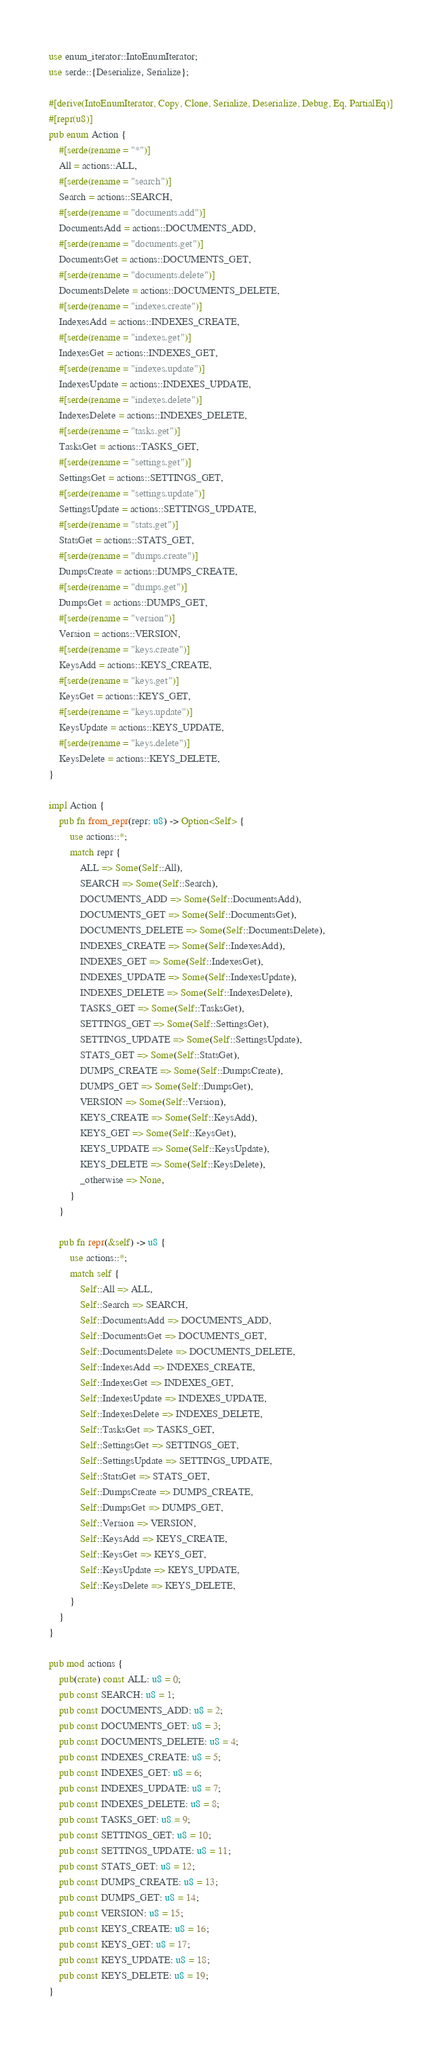<code> <loc_0><loc_0><loc_500><loc_500><_Rust_>use enum_iterator::IntoEnumIterator;
use serde::{Deserialize, Serialize};

#[derive(IntoEnumIterator, Copy, Clone, Serialize, Deserialize, Debug, Eq, PartialEq)]
#[repr(u8)]
pub enum Action {
    #[serde(rename = "*")]
    All = actions::ALL,
    #[serde(rename = "search")]
    Search = actions::SEARCH,
    #[serde(rename = "documents.add")]
    DocumentsAdd = actions::DOCUMENTS_ADD,
    #[serde(rename = "documents.get")]
    DocumentsGet = actions::DOCUMENTS_GET,
    #[serde(rename = "documents.delete")]
    DocumentsDelete = actions::DOCUMENTS_DELETE,
    #[serde(rename = "indexes.create")]
    IndexesAdd = actions::INDEXES_CREATE,
    #[serde(rename = "indexes.get")]
    IndexesGet = actions::INDEXES_GET,
    #[serde(rename = "indexes.update")]
    IndexesUpdate = actions::INDEXES_UPDATE,
    #[serde(rename = "indexes.delete")]
    IndexesDelete = actions::INDEXES_DELETE,
    #[serde(rename = "tasks.get")]
    TasksGet = actions::TASKS_GET,
    #[serde(rename = "settings.get")]
    SettingsGet = actions::SETTINGS_GET,
    #[serde(rename = "settings.update")]
    SettingsUpdate = actions::SETTINGS_UPDATE,
    #[serde(rename = "stats.get")]
    StatsGet = actions::STATS_GET,
    #[serde(rename = "dumps.create")]
    DumpsCreate = actions::DUMPS_CREATE,
    #[serde(rename = "dumps.get")]
    DumpsGet = actions::DUMPS_GET,
    #[serde(rename = "version")]
    Version = actions::VERSION,
    #[serde(rename = "keys.create")]
    KeysAdd = actions::KEYS_CREATE,
    #[serde(rename = "keys.get")]
    KeysGet = actions::KEYS_GET,
    #[serde(rename = "keys.update")]
    KeysUpdate = actions::KEYS_UPDATE,
    #[serde(rename = "keys.delete")]
    KeysDelete = actions::KEYS_DELETE,
}

impl Action {
    pub fn from_repr(repr: u8) -> Option<Self> {
        use actions::*;
        match repr {
            ALL => Some(Self::All),
            SEARCH => Some(Self::Search),
            DOCUMENTS_ADD => Some(Self::DocumentsAdd),
            DOCUMENTS_GET => Some(Self::DocumentsGet),
            DOCUMENTS_DELETE => Some(Self::DocumentsDelete),
            INDEXES_CREATE => Some(Self::IndexesAdd),
            INDEXES_GET => Some(Self::IndexesGet),
            INDEXES_UPDATE => Some(Self::IndexesUpdate),
            INDEXES_DELETE => Some(Self::IndexesDelete),
            TASKS_GET => Some(Self::TasksGet),
            SETTINGS_GET => Some(Self::SettingsGet),
            SETTINGS_UPDATE => Some(Self::SettingsUpdate),
            STATS_GET => Some(Self::StatsGet),
            DUMPS_CREATE => Some(Self::DumpsCreate),
            DUMPS_GET => Some(Self::DumpsGet),
            VERSION => Some(Self::Version),
            KEYS_CREATE => Some(Self::KeysAdd),
            KEYS_GET => Some(Self::KeysGet),
            KEYS_UPDATE => Some(Self::KeysUpdate),
            KEYS_DELETE => Some(Self::KeysDelete),
            _otherwise => None,
        }
    }

    pub fn repr(&self) -> u8 {
        use actions::*;
        match self {
            Self::All => ALL,
            Self::Search => SEARCH,
            Self::DocumentsAdd => DOCUMENTS_ADD,
            Self::DocumentsGet => DOCUMENTS_GET,
            Self::DocumentsDelete => DOCUMENTS_DELETE,
            Self::IndexesAdd => INDEXES_CREATE,
            Self::IndexesGet => INDEXES_GET,
            Self::IndexesUpdate => INDEXES_UPDATE,
            Self::IndexesDelete => INDEXES_DELETE,
            Self::TasksGet => TASKS_GET,
            Self::SettingsGet => SETTINGS_GET,
            Self::SettingsUpdate => SETTINGS_UPDATE,
            Self::StatsGet => STATS_GET,
            Self::DumpsCreate => DUMPS_CREATE,
            Self::DumpsGet => DUMPS_GET,
            Self::Version => VERSION,
            Self::KeysAdd => KEYS_CREATE,
            Self::KeysGet => KEYS_GET,
            Self::KeysUpdate => KEYS_UPDATE,
            Self::KeysDelete => KEYS_DELETE,
        }
    }
}

pub mod actions {
    pub(crate) const ALL: u8 = 0;
    pub const SEARCH: u8 = 1;
    pub const DOCUMENTS_ADD: u8 = 2;
    pub const DOCUMENTS_GET: u8 = 3;
    pub const DOCUMENTS_DELETE: u8 = 4;
    pub const INDEXES_CREATE: u8 = 5;
    pub const INDEXES_GET: u8 = 6;
    pub const INDEXES_UPDATE: u8 = 7;
    pub const INDEXES_DELETE: u8 = 8;
    pub const TASKS_GET: u8 = 9;
    pub const SETTINGS_GET: u8 = 10;
    pub const SETTINGS_UPDATE: u8 = 11;
    pub const STATS_GET: u8 = 12;
    pub const DUMPS_CREATE: u8 = 13;
    pub const DUMPS_GET: u8 = 14;
    pub const VERSION: u8 = 15;
    pub const KEYS_CREATE: u8 = 16;
    pub const KEYS_GET: u8 = 17;
    pub const KEYS_UPDATE: u8 = 18;
    pub const KEYS_DELETE: u8 = 19;
}
</code> 